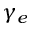<formula> <loc_0><loc_0><loc_500><loc_500>\gamma _ { e }</formula> 